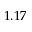Convert formula to latex. <formula><loc_0><loc_0><loc_500><loc_500>1 . 1 7</formula> 